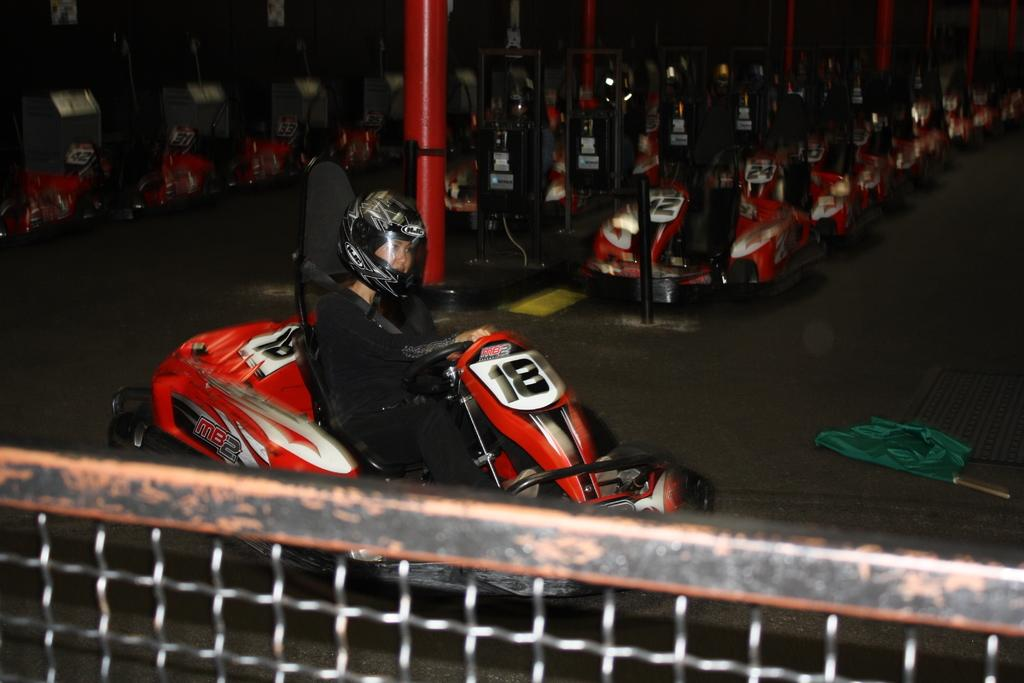What is in the foreground of the image? There is a mesh in the foreground of the image. What can be seen behind the mesh? There is a person sitting in a vehicle behind the mesh. What is visible behind the person? There are poles visible behind the person. What else can be seen in the background of the image? There are multiple vehicles in the background of the image. Where is the notebook placed in the image? There is no notebook present in the image. How many children are visible in the image? There are no children visible in the image. 